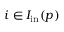Convert formula to latex. <formula><loc_0><loc_0><loc_500><loc_500>i \in I _ { i n } ( p )</formula> 